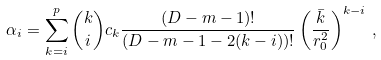<formula> <loc_0><loc_0><loc_500><loc_500>\alpha _ { i } = \sum _ { k = i } ^ { p } { k \choose i } c _ { k } \frac { ( D - m - 1 ) ! } { ( D - m - 1 - 2 ( k - i ) ) ! } \left ( \frac { \bar { k } } { r _ { 0 } ^ { 2 } } \right ) ^ { k - i } \, ,</formula> 